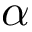Convert formula to latex. <formula><loc_0><loc_0><loc_500><loc_500>\alpha</formula> 